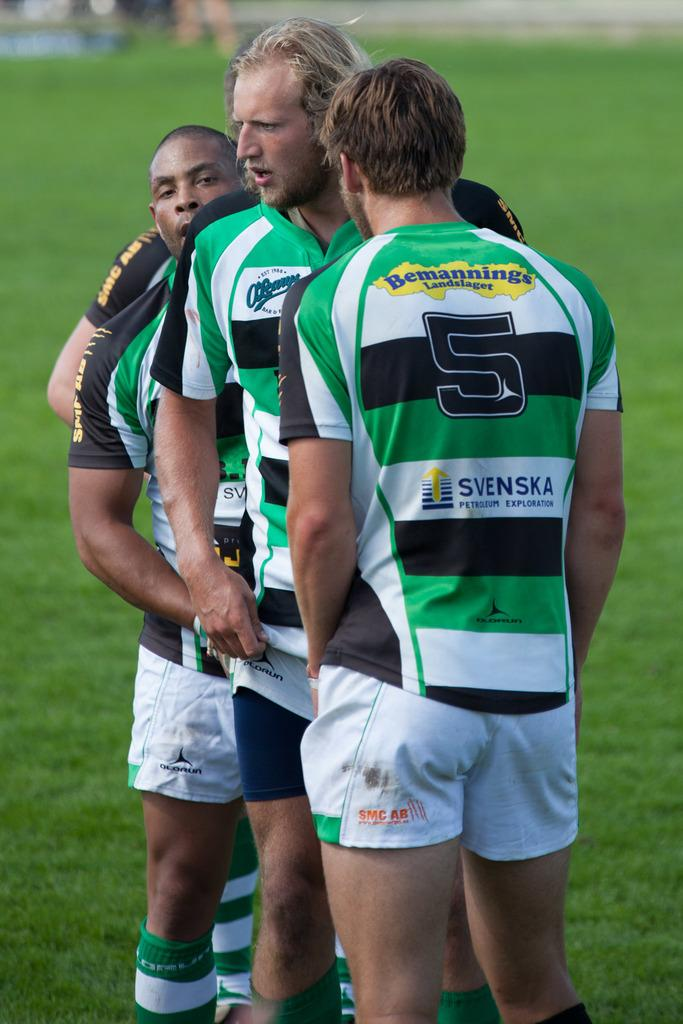Provide a one-sentence caption for the provided image. Three athletes on a field wearing green striped shirts with the number 5 on the first one. 